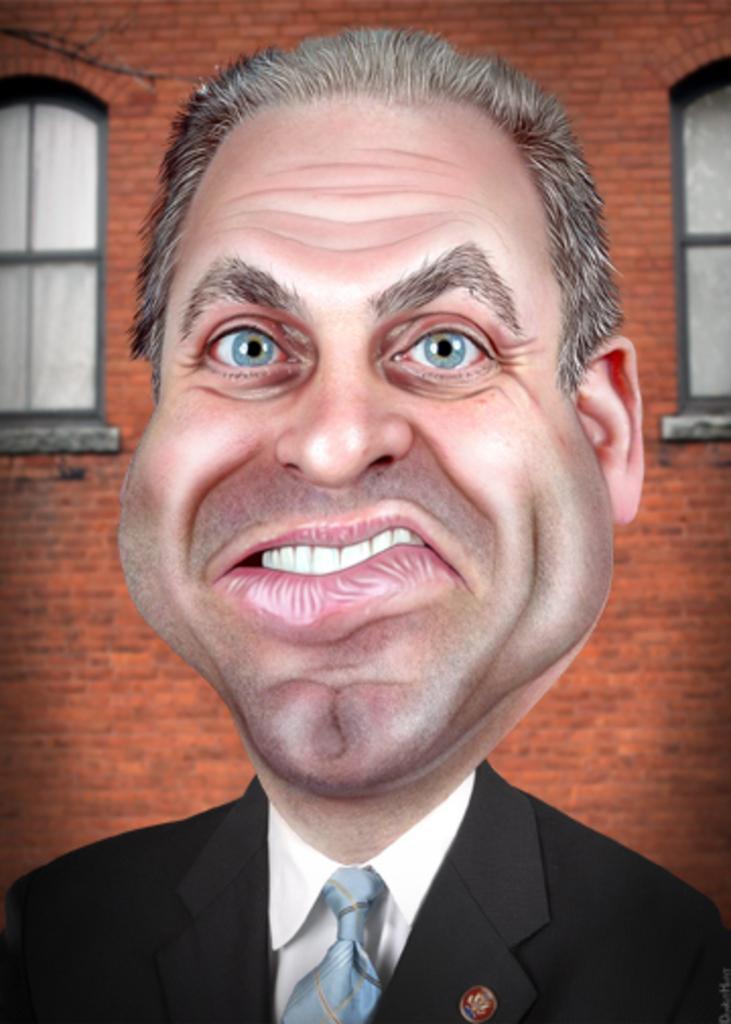Please provide a concise description of this image. This image is an animated image. In the background there is a wall with two windows. In the middle of the image there is a man with a weird face. He has won a suit, a tie and a shirt. 